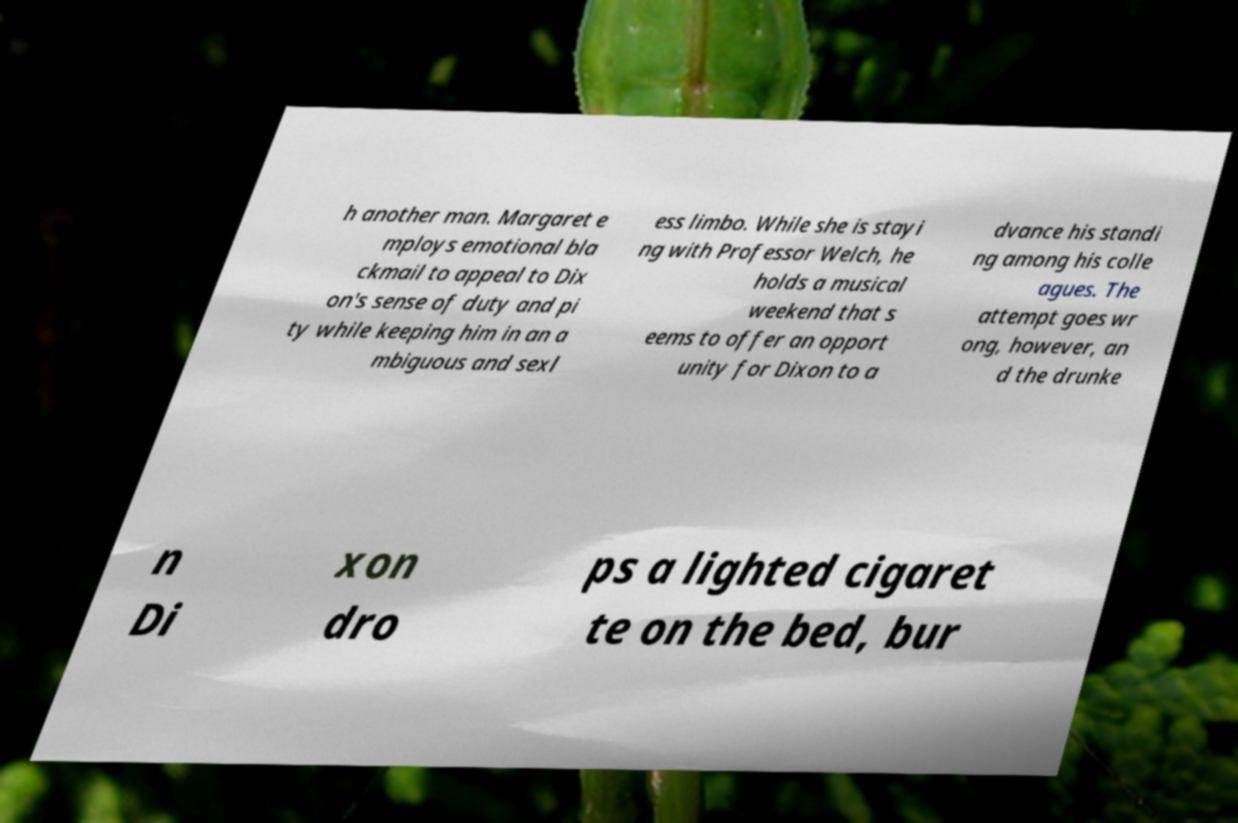Can you read and provide the text displayed in the image?This photo seems to have some interesting text. Can you extract and type it out for me? h another man. Margaret e mploys emotional bla ckmail to appeal to Dix on's sense of duty and pi ty while keeping him in an a mbiguous and sexl ess limbo. While she is stayi ng with Professor Welch, he holds a musical weekend that s eems to offer an opport unity for Dixon to a dvance his standi ng among his colle agues. The attempt goes wr ong, however, an d the drunke n Di xon dro ps a lighted cigaret te on the bed, bur 